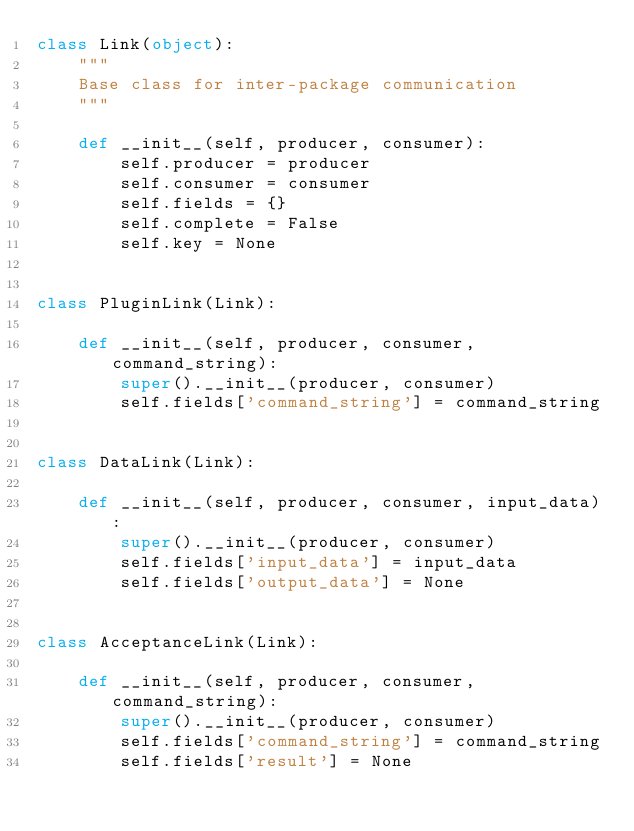<code> <loc_0><loc_0><loc_500><loc_500><_Python_>class Link(object):
    """
    Base class for inter-package communication
    """

    def __init__(self, producer, consumer):
        self.producer = producer
        self.consumer = consumer
        self.fields = {}
        self.complete = False
        self.key = None


class PluginLink(Link):

    def __init__(self, producer, consumer, command_string):
        super().__init__(producer, consumer)
        self.fields['command_string'] = command_string


class DataLink(Link):

    def __init__(self, producer, consumer, input_data):
        super().__init__(producer, consumer)
        self.fields['input_data'] = input_data
        self.fields['output_data'] = None


class AcceptanceLink(Link):

    def __init__(self, producer, consumer, command_string):
        super().__init__(producer, consumer)
        self.fields['command_string'] = command_string
        self.fields['result'] = None
</code> 